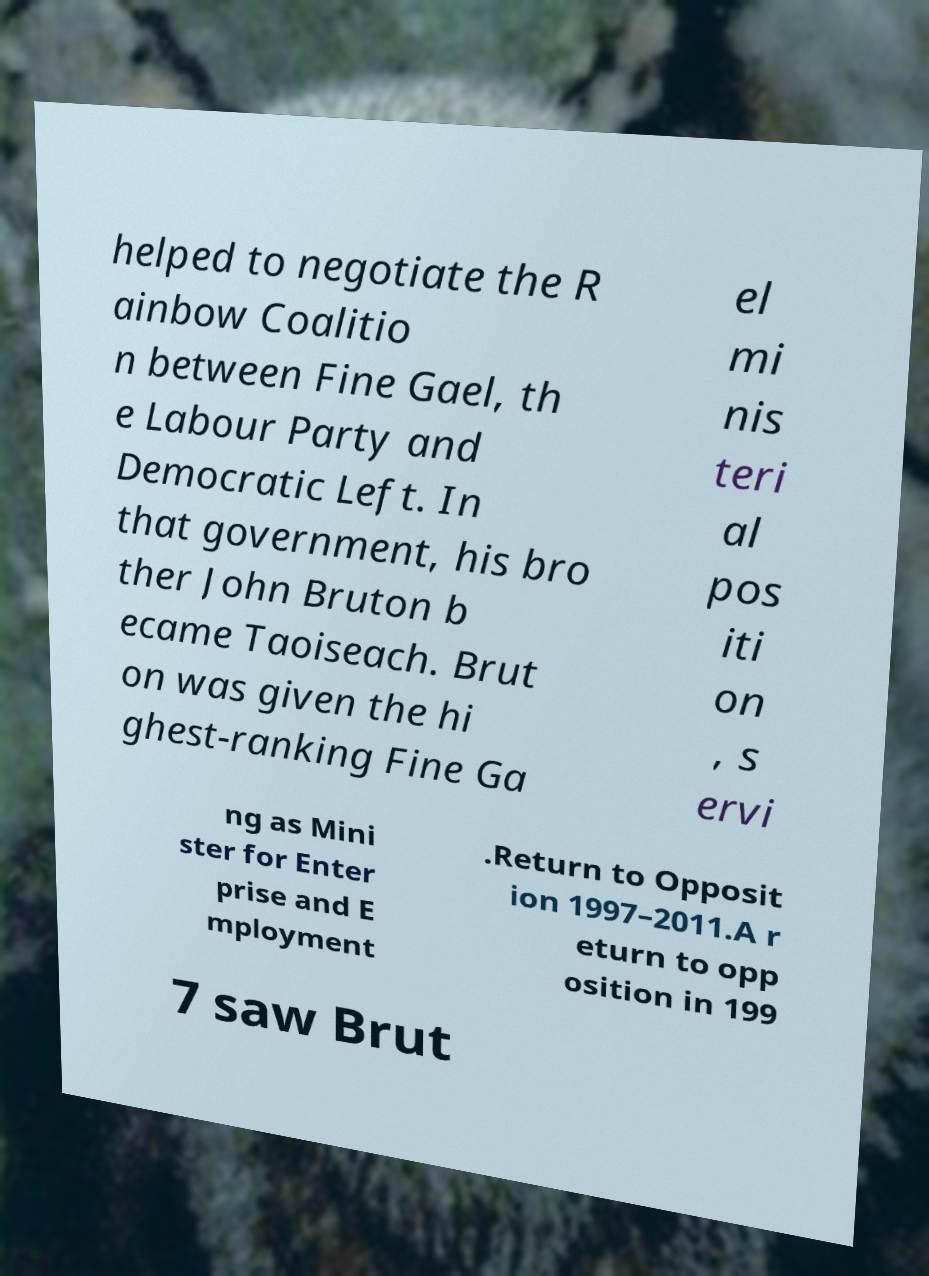I need the written content from this picture converted into text. Can you do that? helped to negotiate the R ainbow Coalitio n between Fine Gael, th e Labour Party and Democratic Left. In that government, his bro ther John Bruton b ecame Taoiseach. Brut on was given the hi ghest-ranking Fine Ga el mi nis teri al pos iti on , s ervi ng as Mini ster for Enter prise and E mployment .Return to Opposit ion 1997–2011.A r eturn to opp osition in 199 7 saw Brut 